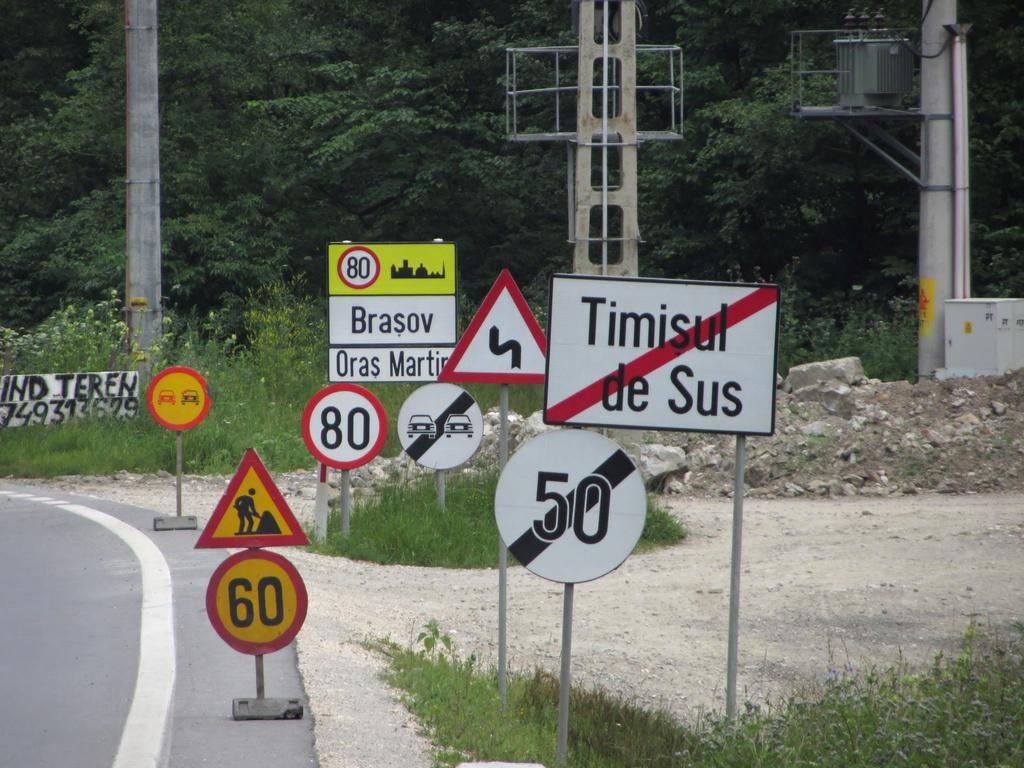<image>
Give a short and clear explanation of the subsequent image. Several road signs, one of which has the word Brasov written on it. 